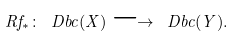Convert formula to latex. <formula><loc_0><loc_0><loc_500><loc_500>R f _ { * } \colon \ D b c ( X ) \longrightarrow \ D b c ( Y ) .</formula> 